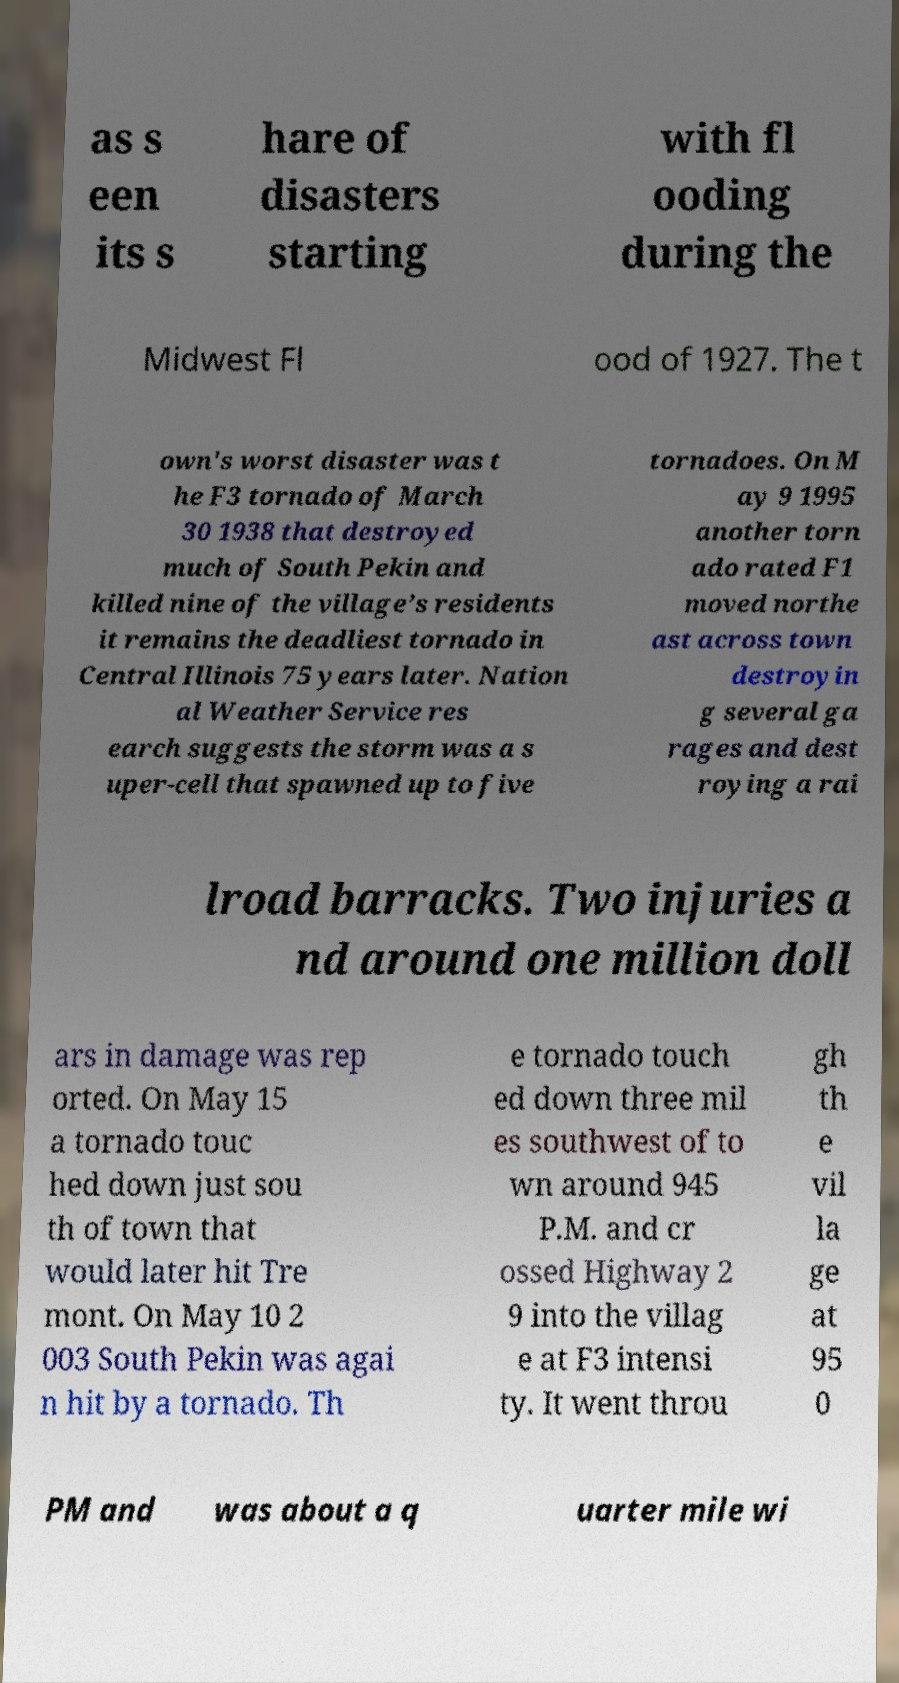Can you accurately transcribe the text from the provided image for me? as s een its s hare of disasters starting with fl ooding during the Midwest Fl ood of 1927. The t own's worst disaster was t he F3 tornado of March 30 1938 that destroyed much of South Pekin and killed nine of the village’s residents it remains the deadliest tornado in Central Illinois 75 years later. Nation al Weather Service res earch suggests the storm was a s uper-cell that spawned up to five tornadoes. On M ay 9 1995 another torn ado rated F1 moved northe ast across town destroyin g several ga rages and dest roying a rai lroad barracks. Two injuries a nd around one million doll ars in damage was rep orted. On May 15 a tornado touc hed down just sou th of town that would later hit Tre mont. On May 10 2 003 South Pekin was agai n hit by a tornado. Th e tornado touch ed down three mil es southwest of to wn around 945 P.M. and cr ossed Highway 2 9 into the villag e at F3 intensi ty. It went throu gh th e vil la ge at 95 0 PM and was about a q uarter mile wi 